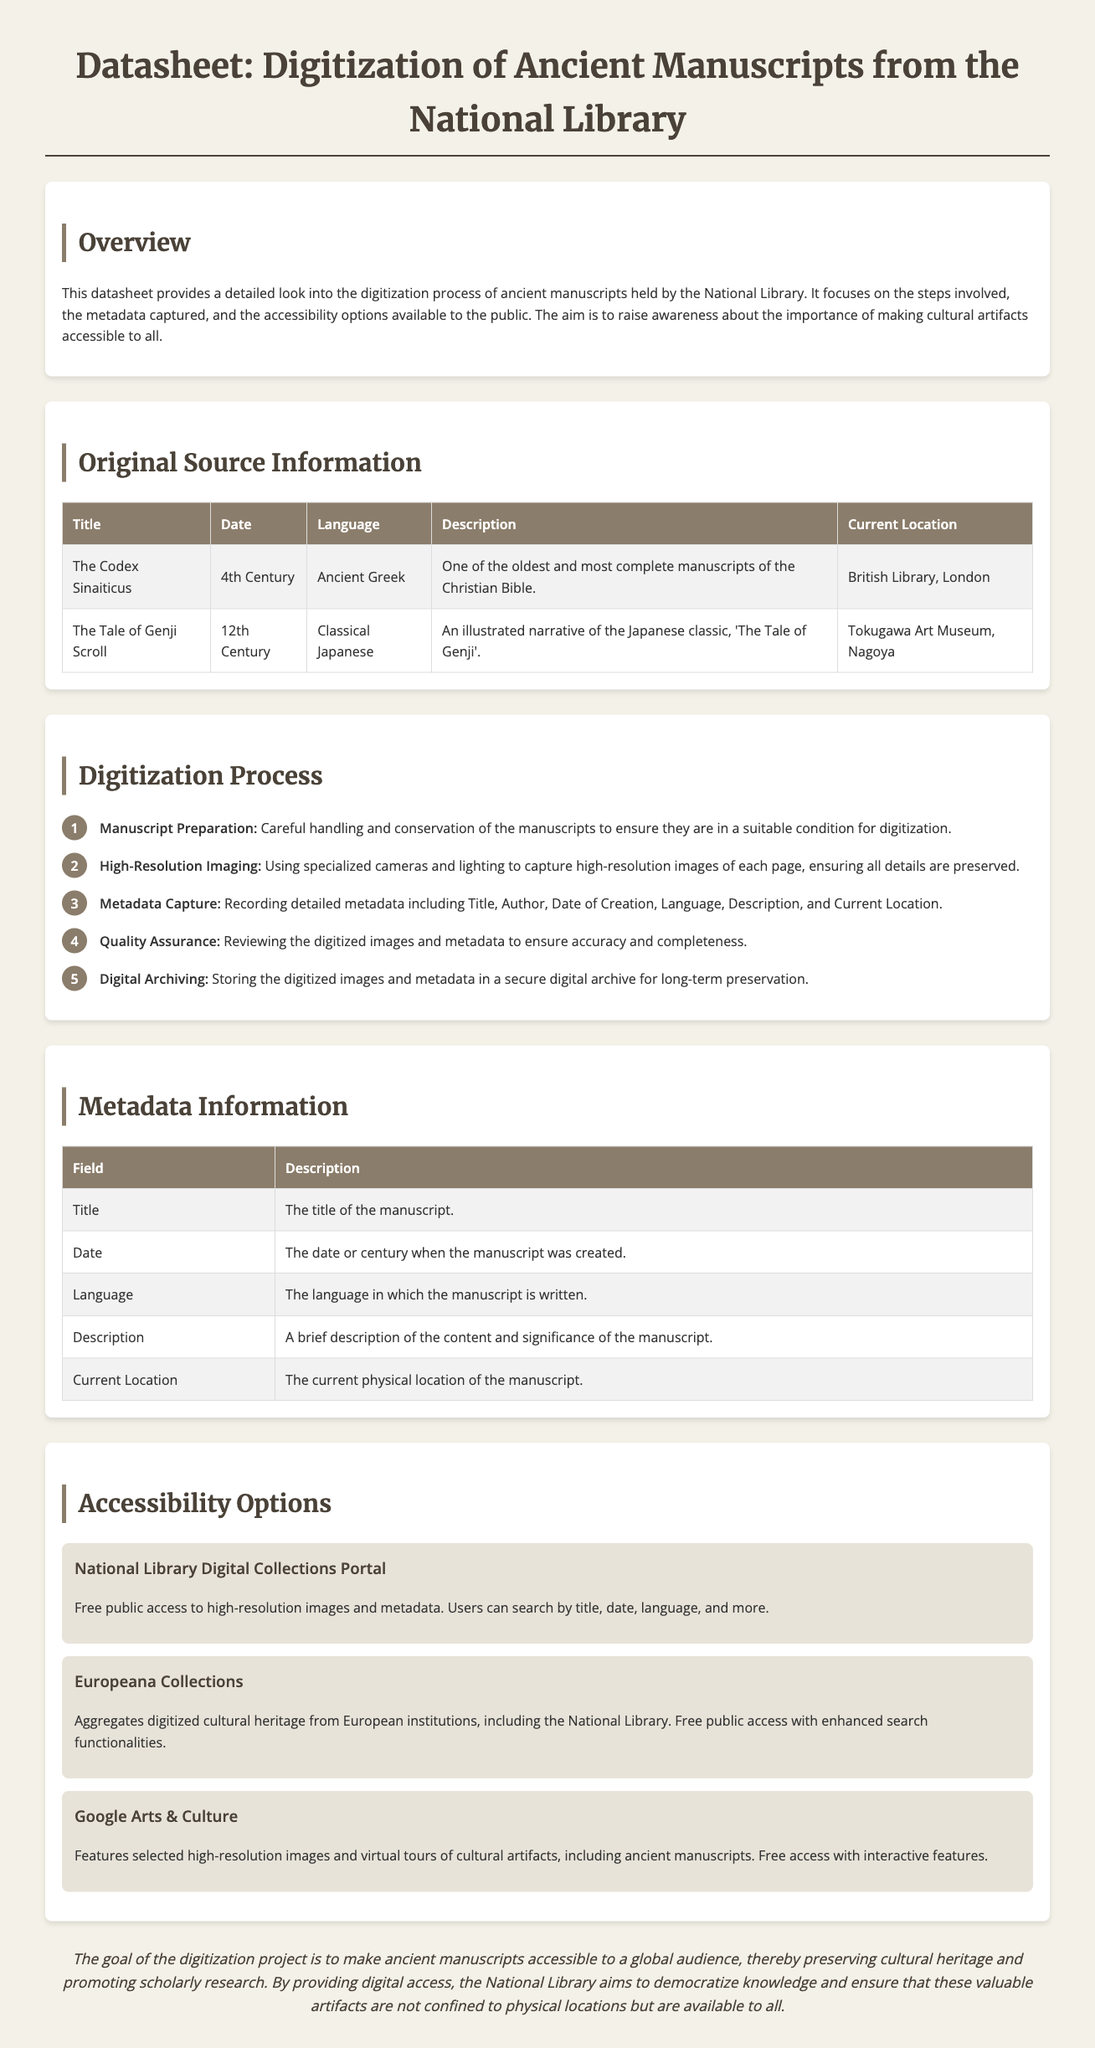what is the title of the first manuscript listed? The first manuscript mentioned in the document is "The Codex Sinaiticus."
Answer: The Codex Sinaiticus what is the date of the second manuscript? The second manuscript, "The Tale of Genji Scroll," is dated to the 12th Century.
Answer: 12th Century which platform provides free public access to high-resolution images? The "National Library Digital Collections Portal" offers free public access to high-resolution images and metadata.
Answer: National Library Digital Collections Portal how many steps are in the digitization process? There are five steps in the digitization process outlined in the document.
Answer: 5 what language is "The Codex Sinaiticus" written in? "The Codex Sinaiticus" is written in Ancient Greek.
Answer: Ancient Greek what is included in the metadata capture? The metadata capture includes Title, Author, Date of Creation, Language, Description, and Current Location.
Answer: Title, Author, Date of Creation, Language, Description, Current Location what is the current location of "The Tale of Genji Scroll"? "The Tale of Genji Scroll" is currently located at the Tokugawa Art Museum in Nagoya.
Answer: Tokugawa Art Museum, Nagoya what is the objective of the digitization project? The goal of the digitization project is to make ancient manuscripts accessible to a global audience.
Answer: Accessible to a global audience 